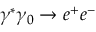<formula> <loc_0><loc_0><loc_500><loc_500>\gamma ^ { * } \gamma _ { 0 } \rightarrow e ^ { + } e ^ { - }</formula> 